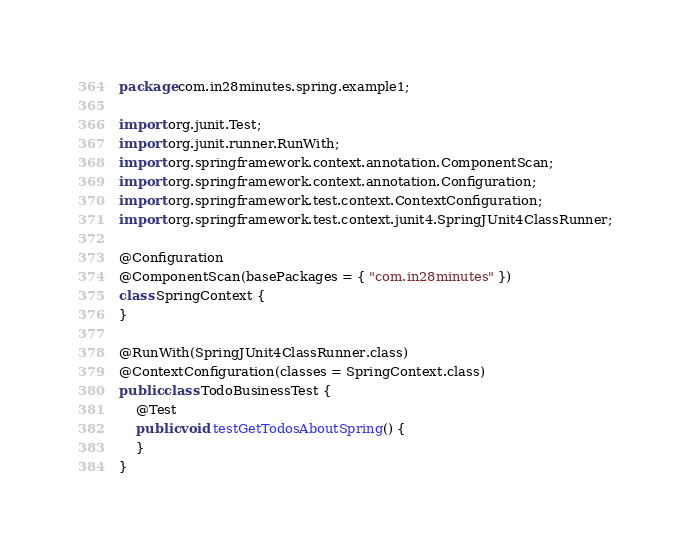Convert code to text. <code><loc_0><loc_0><loc_500><loc_500><_Java_>package com.in28minutes.spring.example1;

import org.junit.Test;
import org.junit.runner.RunWith;
import org.springframework.context.annotation.ComponentScan;
import org.springframework.context.annotation.Configuration;
import org.springframework.test.context.ContextConfiguration;
import org.springframework.test.context.junit4.SpringJUnit4ClassRunner;

@Configuration
@ComponentScan(basePackages = { "com.in28minutes" })
class SpringContext {
}

@RunWith(SpringJUnit4ClassRunner.class)
@ContextConfiguration(classes = SpringContext.class)
public class TodoBusinessTest {
	@Test
	public void testGetTodosAboutSpring() {
	}
}</code> 